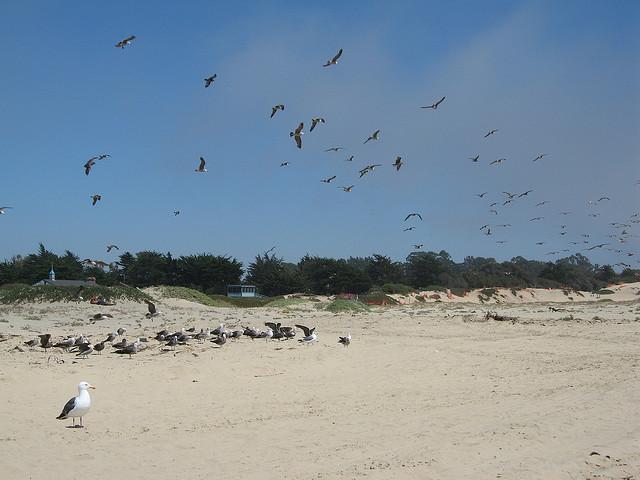How many kites are in the air?
Give a very brief answer. 0. How many kites in this picture?
Give a very brief answer. 0. 